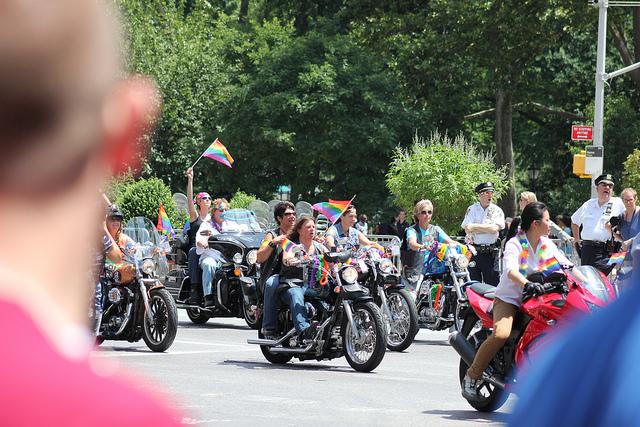Where are the flags?
Give a very brief answer. Air. Are there any women riding motorcycles?
Be succinct. Yes. Are people holding flags?
Quick response, please. Yes. 